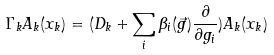Convert formula to latex. <formula><loc_0><loc_0><loc_500><loc_500>\Gamma _ { k } A _ { k } ( x _ { k } ) = ( D _ { k } + \sum _ { i } \beta _ { i } ( \vec { g } ) \frac { \partial } { \partial g _ { i } } ) A _ { k } ( x _ { k } )</formula> 